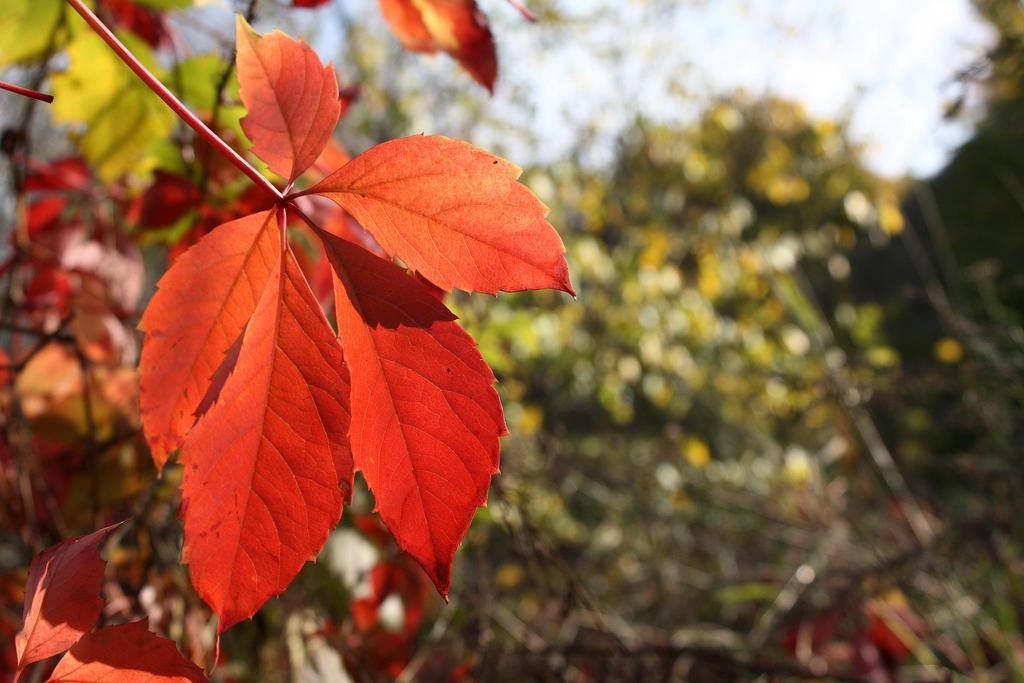What type of vegetation can be seen in the image? There are leaves in the image. What can be seen in the background of the image? There are trees and the sky visible in the background of the image. How would you describe the overall quality of the image? The image is blurry. What type of haircut is the tree on the left side of the image getting? There is no tree on the left side of the image, and trees do not get haircuts. 